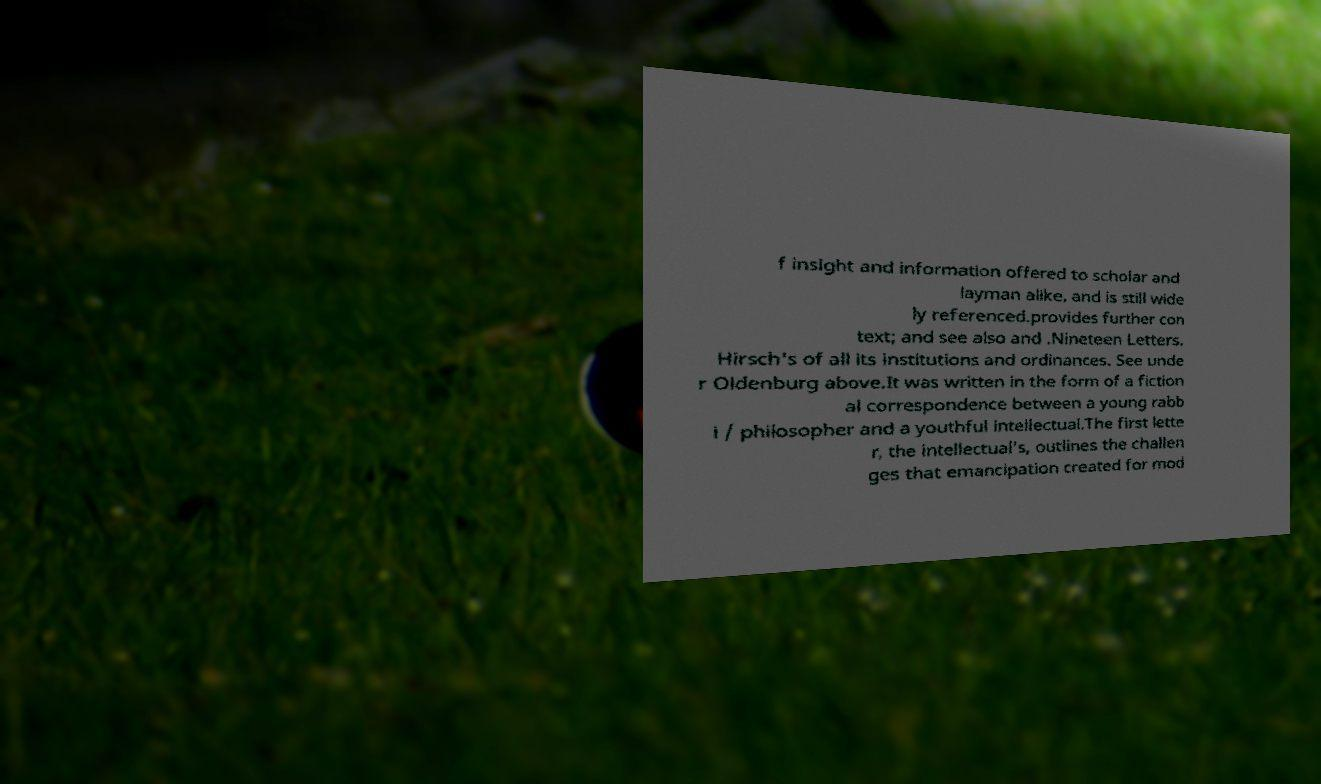Please read and relay the text visible in this image. What does it say? f insight and information offered to scholar and layman alike, and is still wide ly referenced.provides further con text; and see also and .Nineteen Letters. Hirsch's of all its institutions and ordinances. See unde r Oldenburg above.It was written in the form of a fiction al correspondence between a young rabb i / philosopher and a youthful intellectual.The first lette r, the intellectual's, outlines the challen ges that emancipation created for mod 